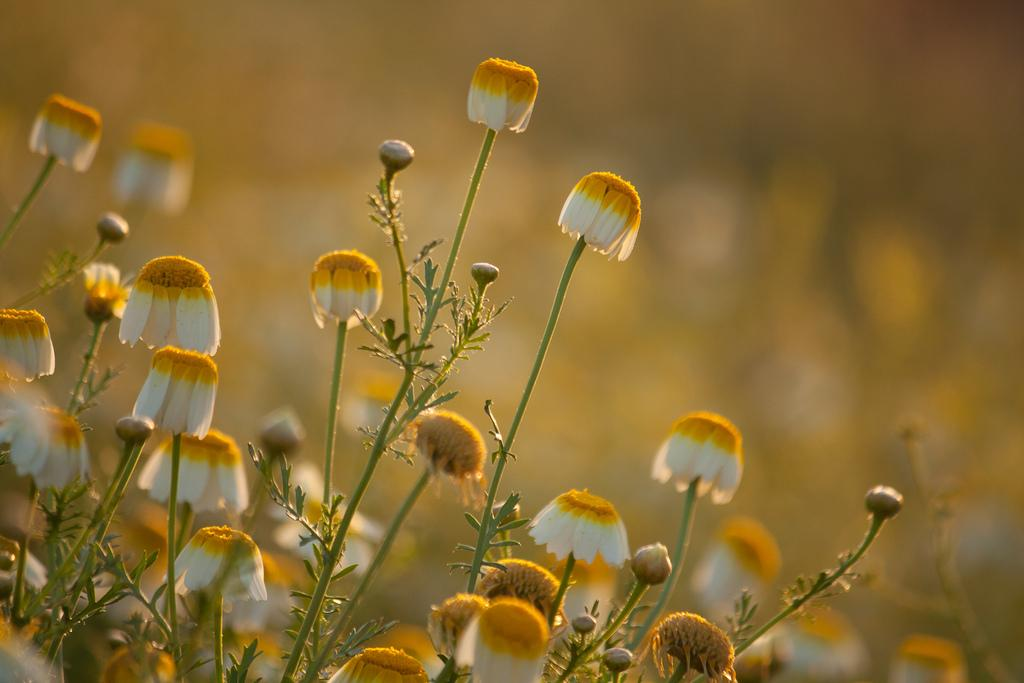What types of living organisms can be seen in the image? Plants and flowers are visible in the image. Can you describe the background of the image? The background of the image is blurred. What type of fang can be seen in the image? There is no fang present in the image; it features plants and flowers. What letters can be seen on the flowers in the image? There are no letters on the flowers in the image. 